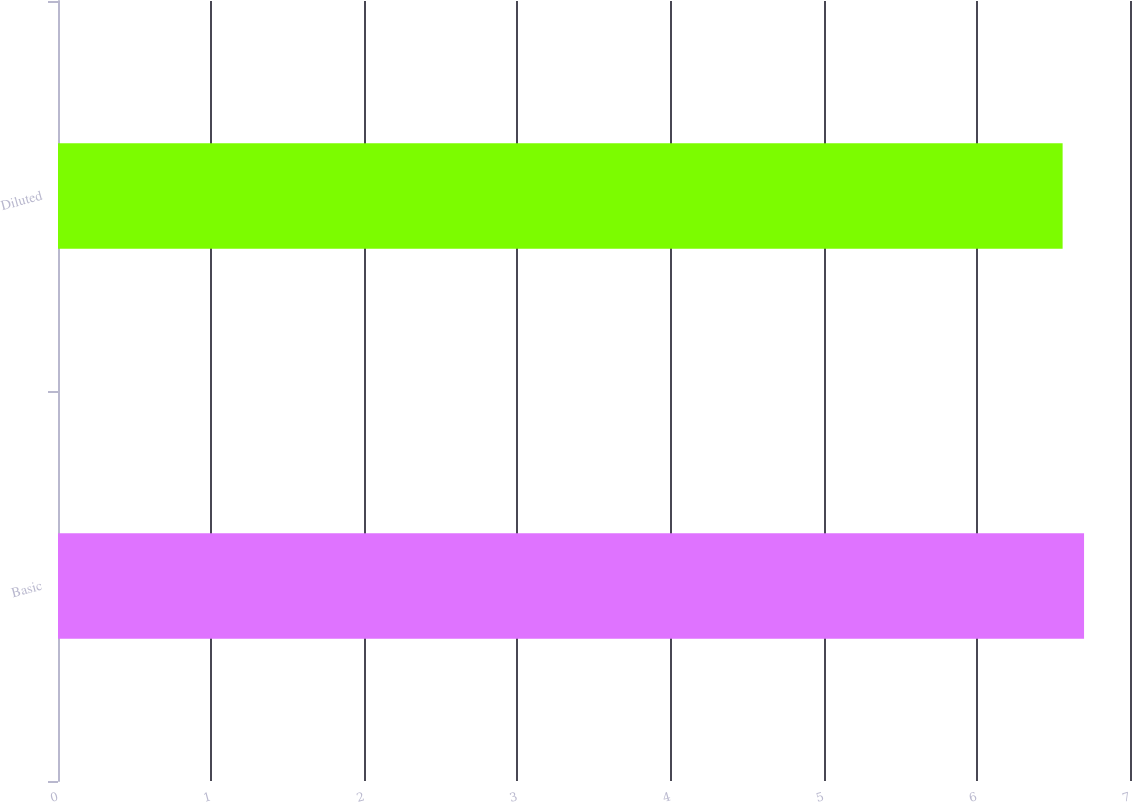Convert chart to OTSL. <chart><loc_0><loc_0><loc_500><loc_500><bar_chart><fcel>Basic<fcel>Diluted<nl><fcel>6.7<fcel>6.56<nl></chart> 